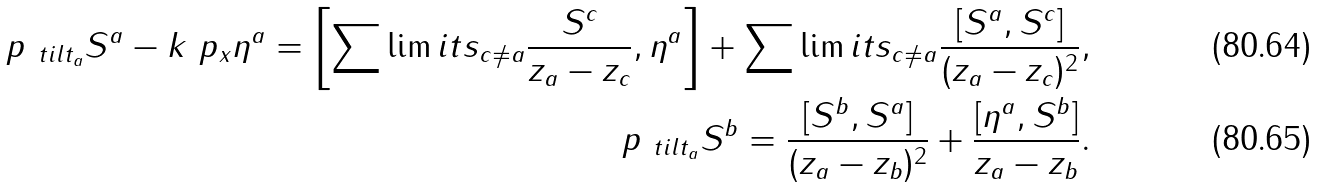<formula> <loc_0><loc_0><loc_500><loc_500>\ p _ { \ t i l t _ { a } } S ^ { a } - k \ p _ { x } \eta ^ { a } = \left [ \sum \lim i t s _ { c \neq a } \frac { S ^ { c } } { z _ { a } - z _ { c } } , \eta ^ { a } \right ] + \sum \lim i t s _ { c \neq a } \frac { [ S ^ { a } , S ^ { c } ] } { ( z _ { a } - z _ { c } ) ^ { 2 } } , \\ \ p _ { \ t i l t _ { a } } S ^ { b } = \frac { [ S ^ { b } , S ^ { a } ] } { ( z _ { a } - z _ { b } ) ^ { 2 } } + \frac { [ \eta ^ { a } , S ^ { b } ] } { z _ { a } - z _ { b } } .</formula> 